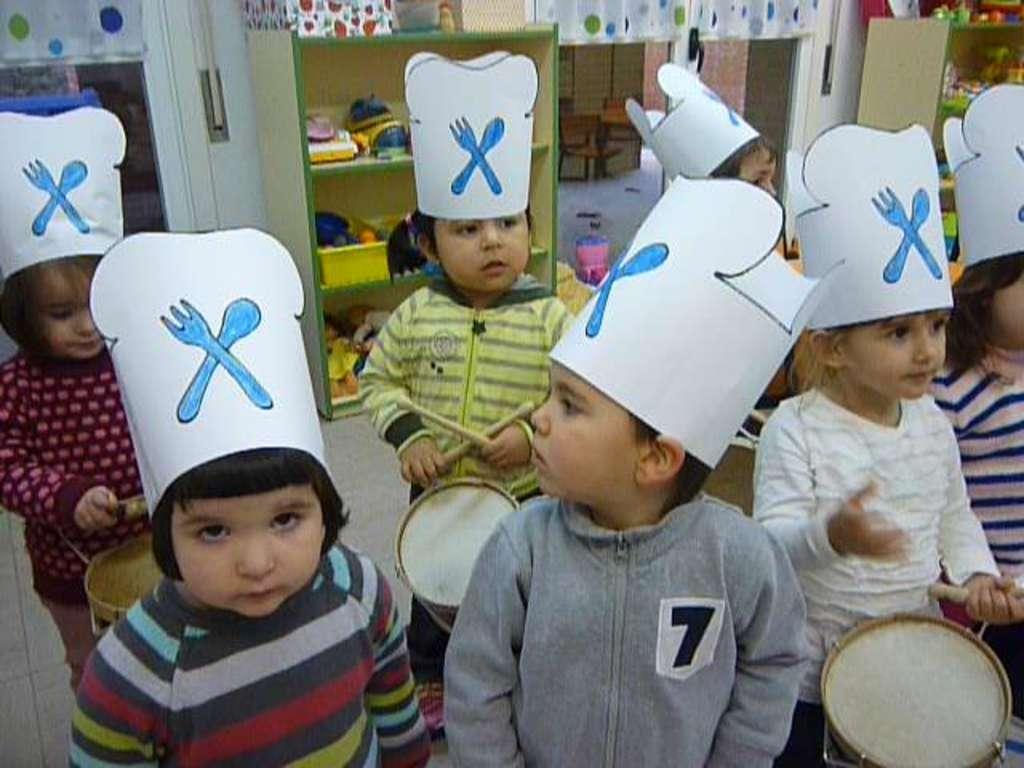Can you describe this image briefly? As we can see in the image, there are few people standing and wearing a hat over there head. Behind them there are few shelves and there is a white color wall. 